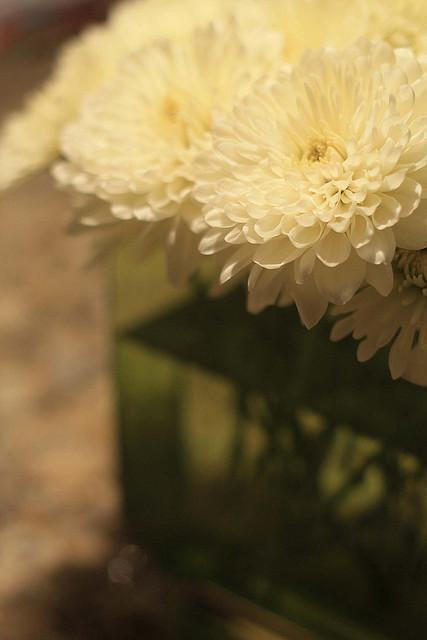How many vases are visible?
Give a very brief answer. 1. 